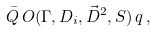<formula> <loc_0><loc_0><loc_500><loc_500>\bar { Q } \, O ( \Gamma , D _ { i } , \vec { D } ^ { 2 } , S ) \, q \, ,</formula> 